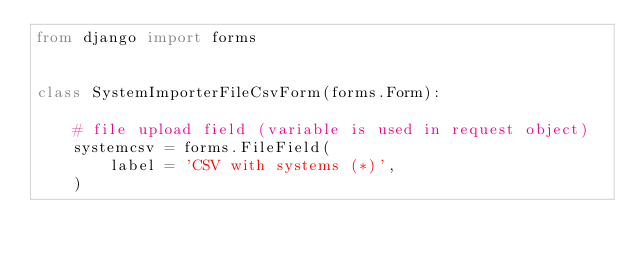<code> <loc_0><loc_0><loc_500><loc_500><_Python_>from django import forms


class SystemImporterFileCsvForm(forms.Form):

    # file upload field (variable is used in request object)
    systemcsv = forms.FileField(
        label = 'CSV with systems (*)',
    )
</code> 